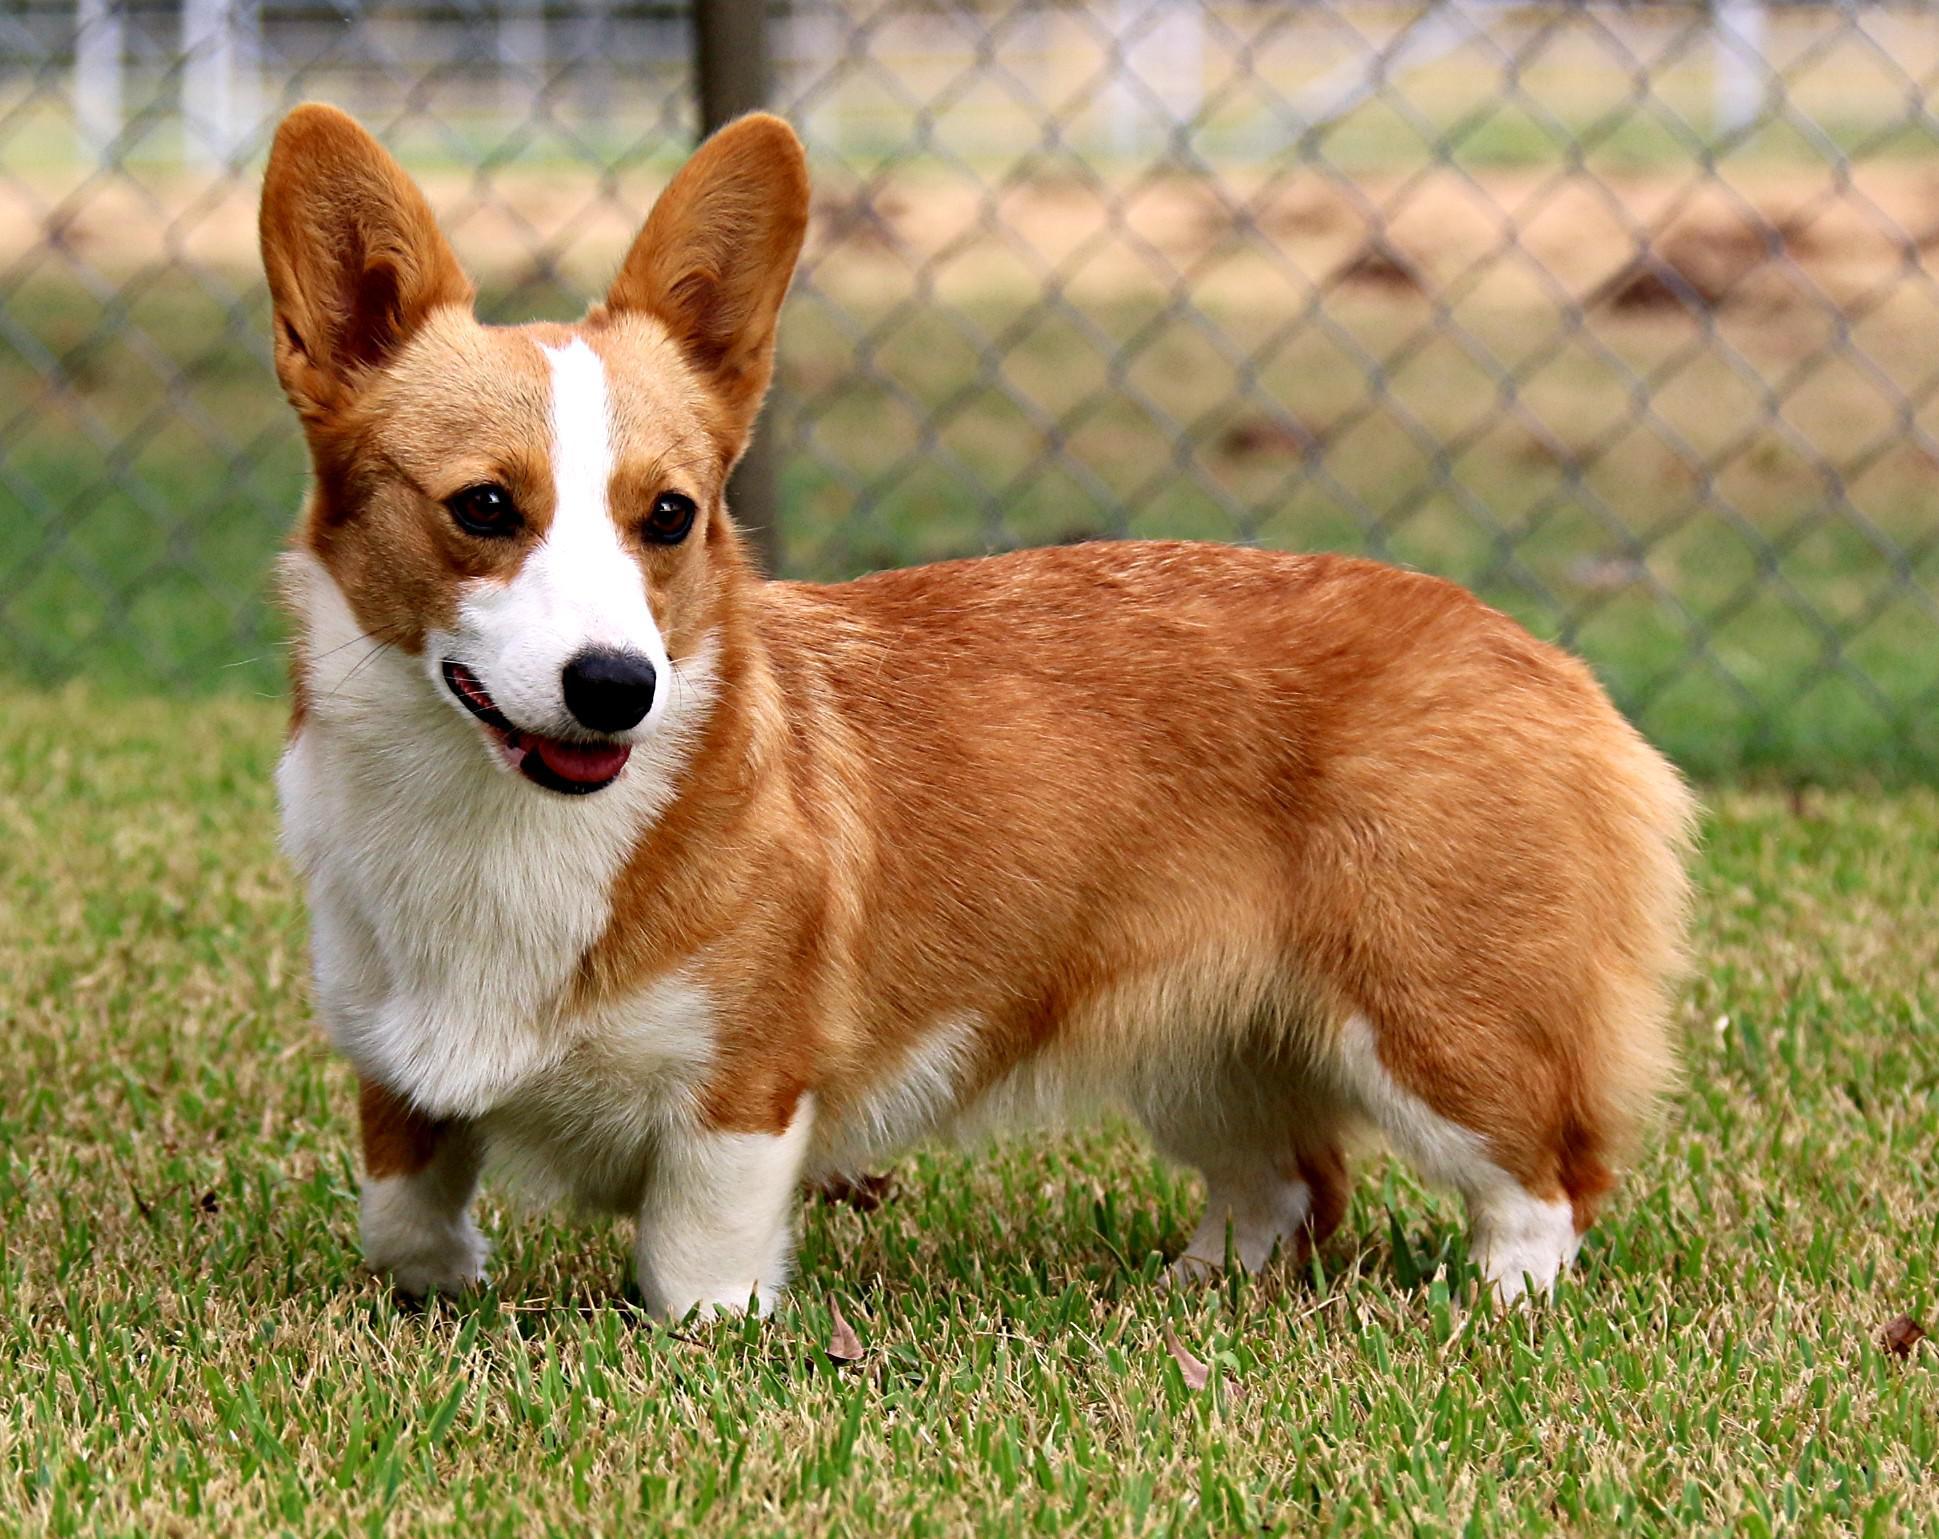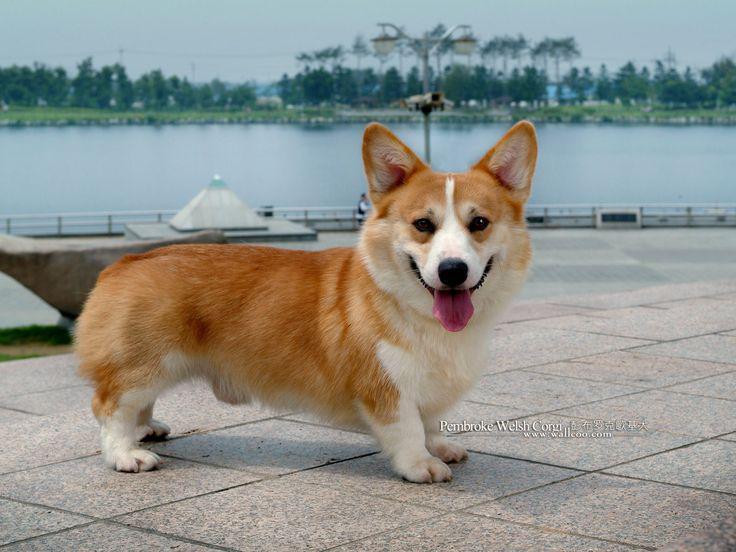The first image is the image on the left, the second image is the image on the right. Evaluate the accuracy of this statement regarding the images: "Three dogs are visible.". Is it true? Answer yes or no. No. The first image is the image on the left, the second image is the image on the right. Evaluate the accuracy of this statement regarding the images: "There are 3 dogs outdoors on the grass.". Is it true? Answer yes or no. No. 